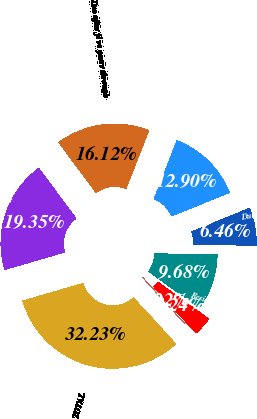Convert chart. <chart><loc_0><loc_0><loc_500><loc_500><pie_chart><fcel>Due in one year or less<fcel>Due after one year through fi<fcel>Due after fi ve years through<fcel>Due after ten years<fcel>TOTAL<fcel>Asset-backed<fcel>Commercial mortgage-backed<fcel>Residential mortgage-backed<nl><fcel>6.46%<fcel>12.9%<fcel>16.12%<fcel>19.35%<fcel>32.23%<fcel>0.02%<fcel>3.24%<fcel>9.68%<nl></chart> 